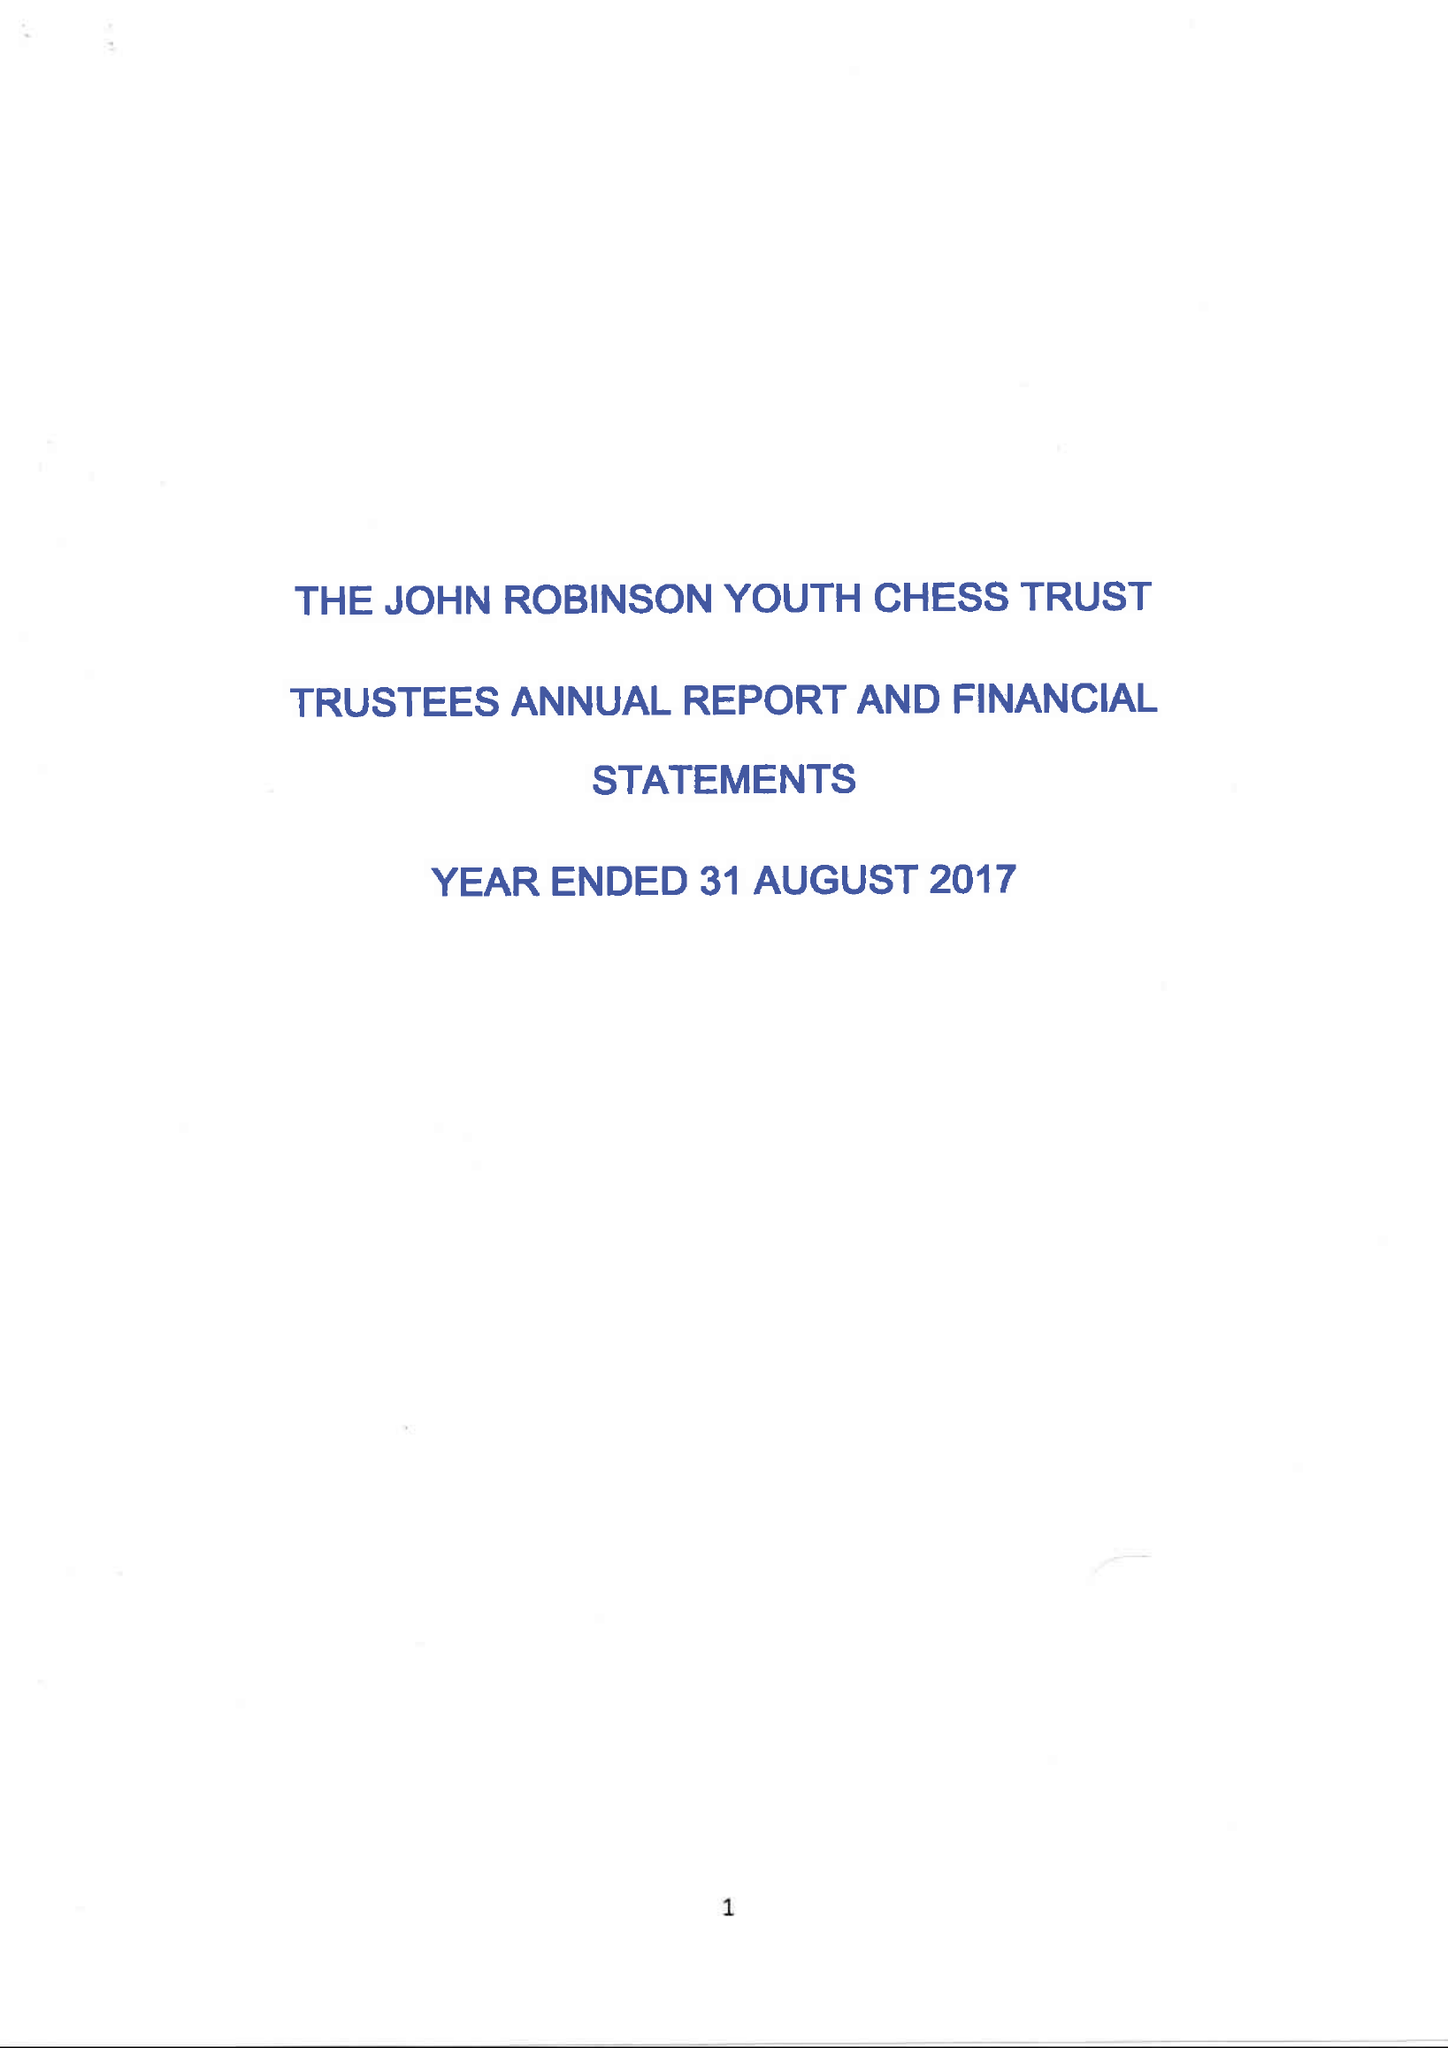What is the value for the income_annually_in_british_pounds?
Answer the question using a single word or phrase. 26639.00 